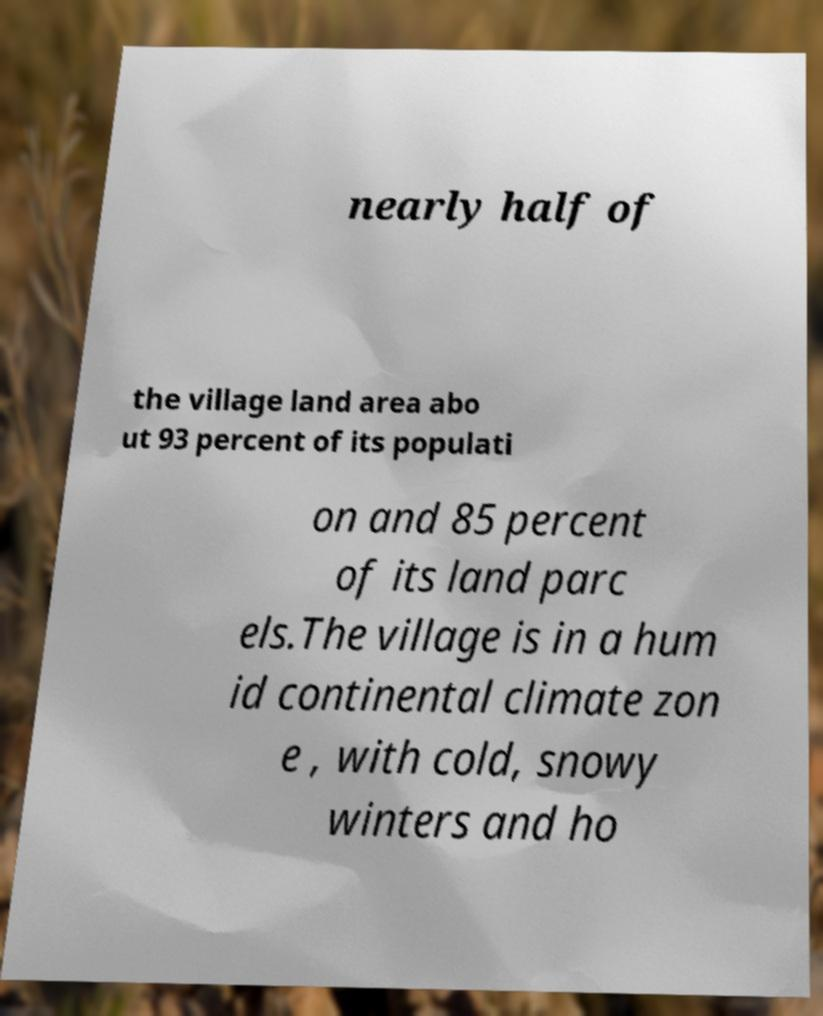Could you extract and type out the text from this image? nearly half of the village land area abo ut 93 percent of its populati on and 85 percent of its land parc els.The village is in a hum id continental climate zon e , with cold, snowy winters and ho 